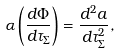Convert formula to latex. <formula><loc_0><loc_0><loc_500><loc_500>\alpha \left ( \frac { d \Phi } { d \tau _ { \Sigma } } \right ) = \frac { d ^ { 2 } a } { d \tau _ { \Sigma } ^ { 2 } } ,</formula> 